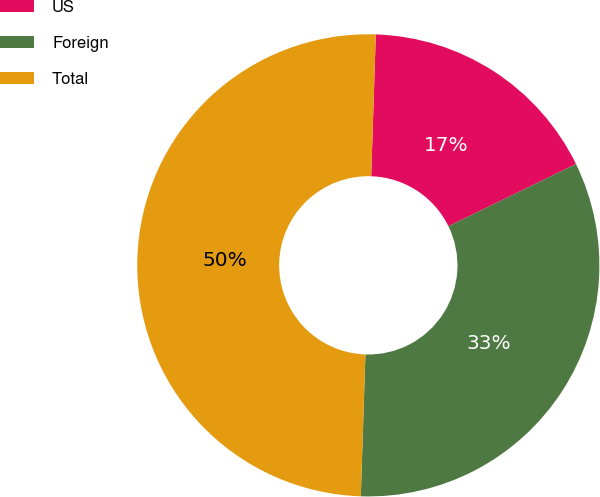<chart> <loc_0><loc_0><loc_500><loc_500><pie_chart><fcel>US<fcel>Foreign<fcel>Total<nl><fcel>17.26%<fcel>32.74%<fcel>50.0%<nl></chart> 